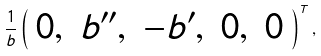<formula> <loc_0><loc_0><loc_500><loc_500>\frac { 1 } { b } \left ( \begin{array} { c c c c c } 0 , & b ^ { \prime \prime } , & - b ^ { \prime } , & 0 , & 0 \end{array} \right ) ^ { T } ,</formula> 